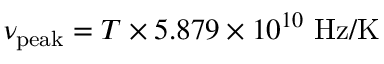Convert formula to latex. <formula><loc_0><loc_0><loc_500><loc_500>\nu _ { p e a k } = T \times 5 . 8 7 9 \times 1 0 ^ { 1 0 } \ H z / K</formula> 